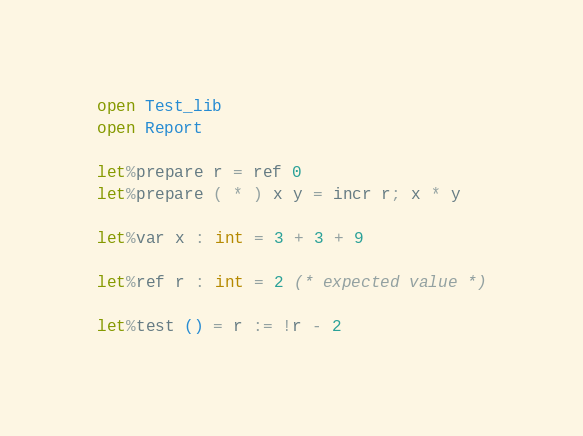<code> <loc_0><loc_0><loc_500><loc_500><_OCaml_>open Test_lib
open Report

let%prepare r = ref 0
let%prepare ( * ) x y = incr r; x * y

let%var x : int = 3 + 3 + 9

let%ref r : int = 2 (* expected value *)

let%test () = r := !r - 2
</code> 